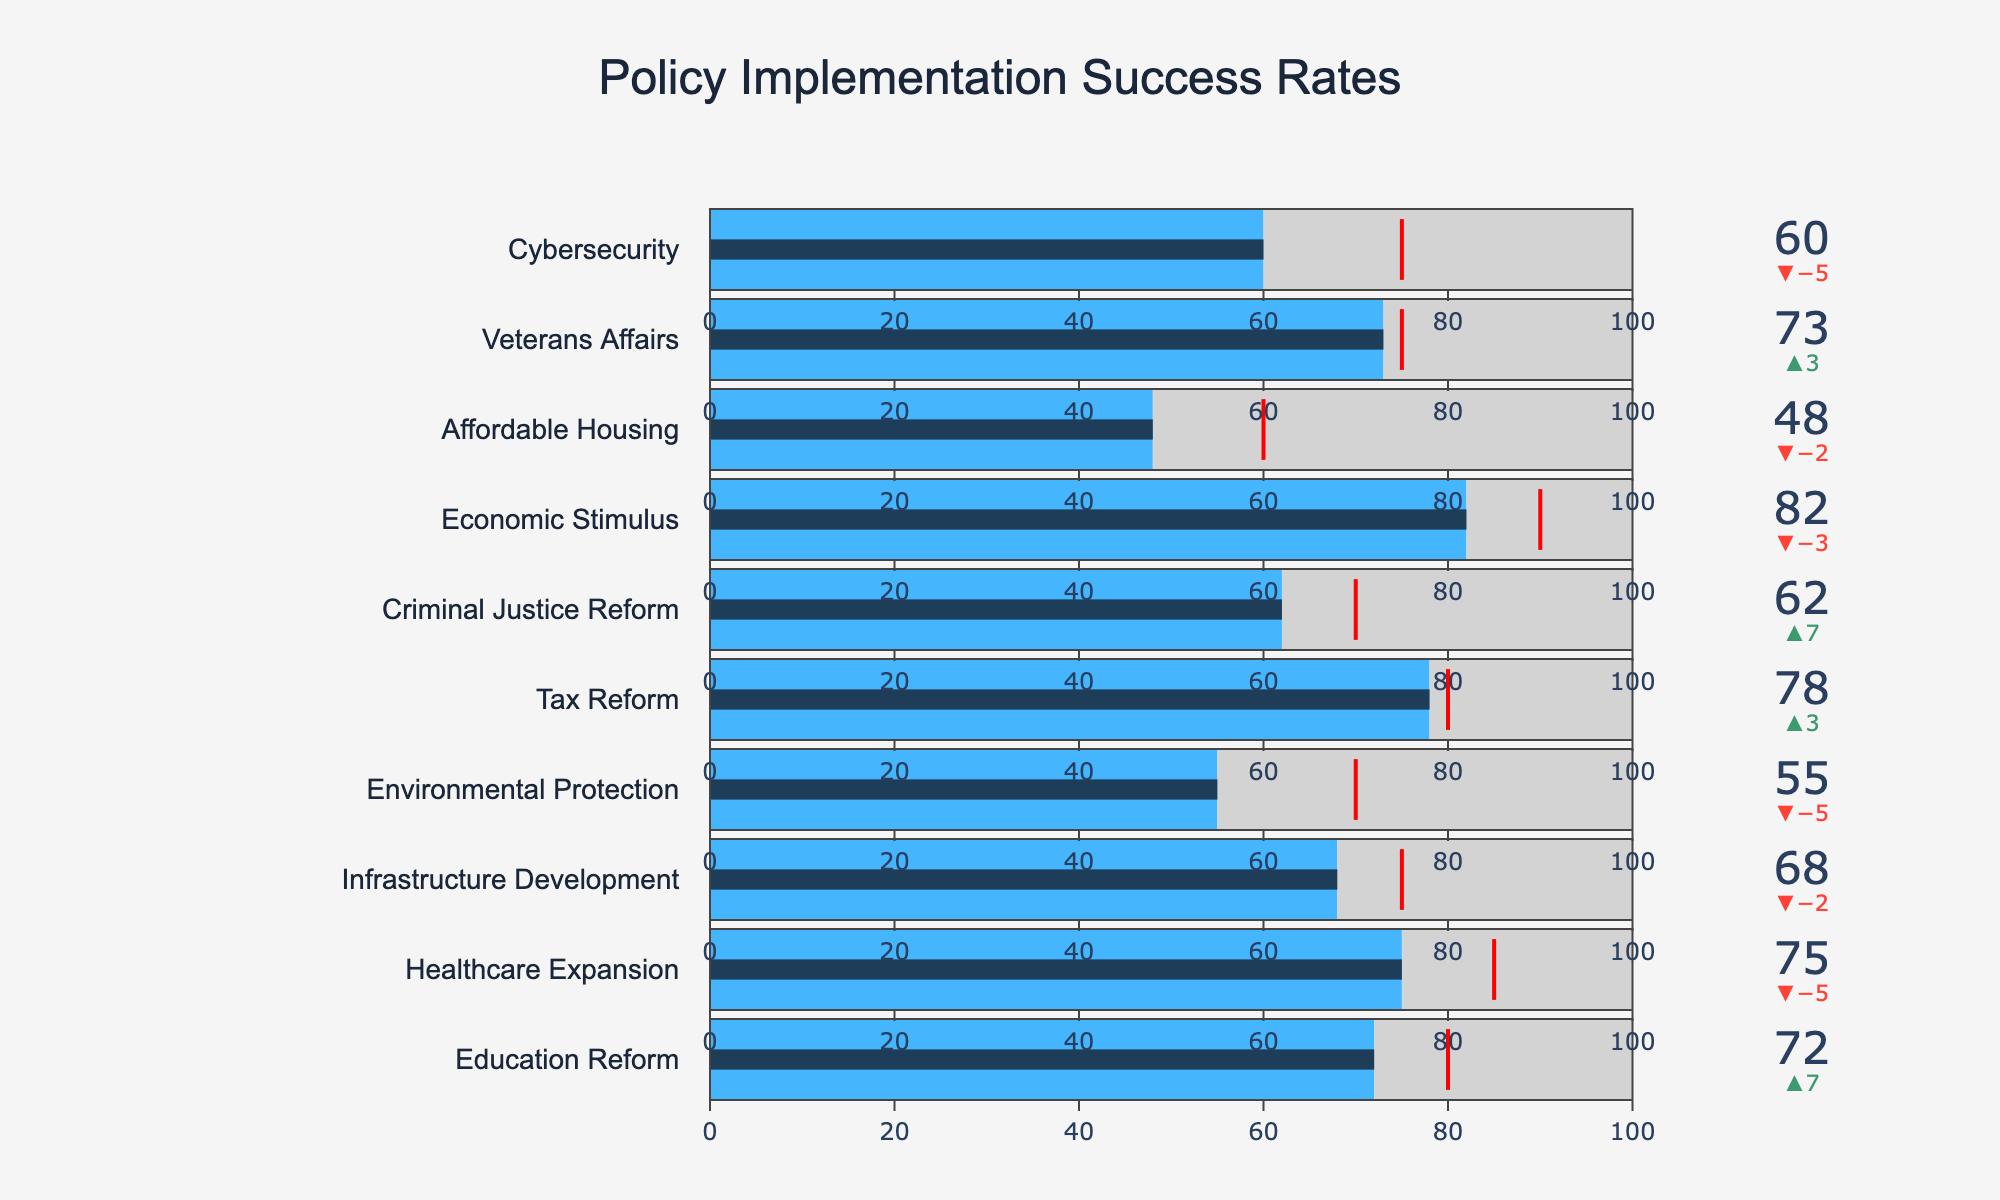How many policies have their actual success rate below the projected success rate? By looking at the delta values (indicated by the difference between projected and actual success rates), we count the number of policies where the actual success rate is less than the projected rate. The policies are Healthcare Expansion, Infrastructure Development, Environmental Protection, Economic Stimulus, Affordable Housing, and Cybersecurity.
Answer: 6 Which policy showed the greatest improvement over its projected success rate? Reviewing the delta values and identifying the policy with the highest positive delta benefit, we see that Education Reform has the most improvement. The delta is 72 - 65 = 7.
Answer: Education Reform Are there more policies that exceed their projected success rate or fall short of it? Count the policies where the actual success rate is greater than the projected and compare it to where the actual is less. Exceeding: Education Reform, Tax Reform, Criminal Justice Reform, Veterans Affairs. Falling Short: Healthcare Expansion, Infrastructure Development, Environmental Protection, Economic Stimulus, Affordable Housing, Cybersecurity.
Answer: Fall short What is the average actual success rate of the policies? Sum the actual success rates of all policies and divide by the number of policies. (72 + 75 + 68 + 55 + 78 + 62 + 82 + 48 + 73 + 60) / 10 = 67.3.
Answer: 67.3 Which policy is closest to meeting its target success rate? Identify the policy where the actual success rate is closest to the target success rate by calculating the absolute difference between the actual and target for each policy. Tax Reform Actual: 78, Target: 80 with an absolute difference of 2.
Answer: Tax Reform How many policies have a target success rate of 75% or higher? Count the policies where the target success rate is greater than or equal to 75. These policies are Education Reform, Healthcare Expansion, Infrastructure Development, Tax Reform, Economic Stimulus, Veterans Affairs, Cybersecurity.
Answer: 7 Which policy has the largest gap between its target success rate and actual success rate? Calculate the difference between the target and actual success rates and find the policy with the largest gap. Environmental Protection Actual: 55, Target: 70 with a difference of 15.
Answer: Environmental Protection What is the overall increase or decrease in the actual success rates compared to the projected success rates for all policies combined? Sum up all the differences between actual and projected success rates: (72-65) + (75-80) + (68-70) + (55-60) + (78-75) + (62-55) + (82-85) + (48-50) + (73-70) + (60-65) = 7 + (-5) + (-2) + (-5) + 3 + 7 + (-3) + (-2) + 3 + (-5) = -2.
Answer: -2 